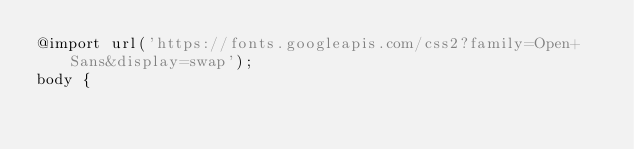Convert code to text. <code><loc_0><loc_0><loc_500><loc_500><_CSS_>@import url('https://fonts.googleapis.com/css2?family=Open+Sans&display=swap');
body {</code> 